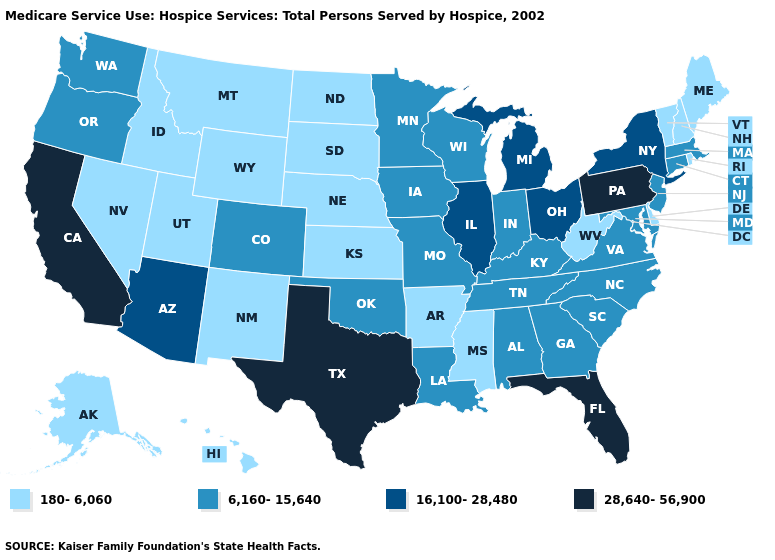What is the value of New Hampshire?
Keep it brief. 180-6,060. Does New Hampshire have a lower value than West Virginia?
Keep it brief. No. Does Kansas have the lowest value in the MidWest?
Give a very brief answer. Yes. What is the value of West Virginia?
Give a very brief answer. 180-6,060. Does South Dakota have the lowest value in the MidWest?
Answer briefly. Yes. Which states have the highest value in the USA?
Concise answer only. California, Florida, Pennsylvania, Texas. What is the highest value in states that border New Jersey?
Be succinct. 28,640-56,900. What is the lowest value in the USA?
Write a very short answer. 180-6,060. What is the value of Vermont?
Answer briefly. 180-6,060. Which states have the lowest value in the USA?
Give a very brief answer. Alaska, Arkansas, Delaware, Hawaii, Idaho, Kansas, Maine, Mississippi, Montana, Nebraska, Nevada, New Hampshire, New Mexico, North Dakota, Rhode Island, South Dakota, Utah, Vermont, West Virginia, Wyoming. Which states have the lowest value in the USA?
Concise answer only. Alaska, Arkansas, Delaware, Hawaii, Idaho, Kansas, Maine, Mississippi, Montana, Nebraska, Nevada, New Hampshire, New Mexico, North Dakota, Rhode Island, South Dakota, Utah, Vermont, West Virginia, Wyoming. Does Nebraska have a lower value than Arkansas?
Write a very short answer. No. Does Idaho have the highest value in the USA?
Keep it brief. No. What is the highest value in states that border South Carolina?
Short answer required. 6,160-15,640. 